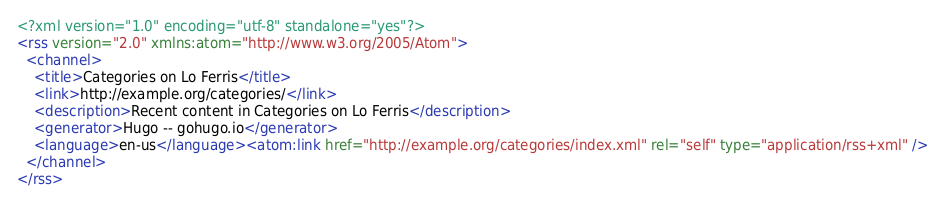<code> <loc_0><loc_0><loc_500><loc_500><_XML_><?xml version="1.0" encoding="utf-8" standalone="yes"?>
<rss version="2.0" xmlns:atom="http://www.w3.org/2005/Atom">
  <channel>
    <title>Categories on Lo Ferris</title>
    <link>http://example.org/categories/</link>
    <description>Recent content in Categories on Lo Ferris</description>
    <generator>Hugo -- gohugo.io</generator>
    <language>en-us</language><atom:link href="http://example.org/categories/index.xml" rel="self" type="application/rss+xml" />
  </channel>
</rss>
</code> 